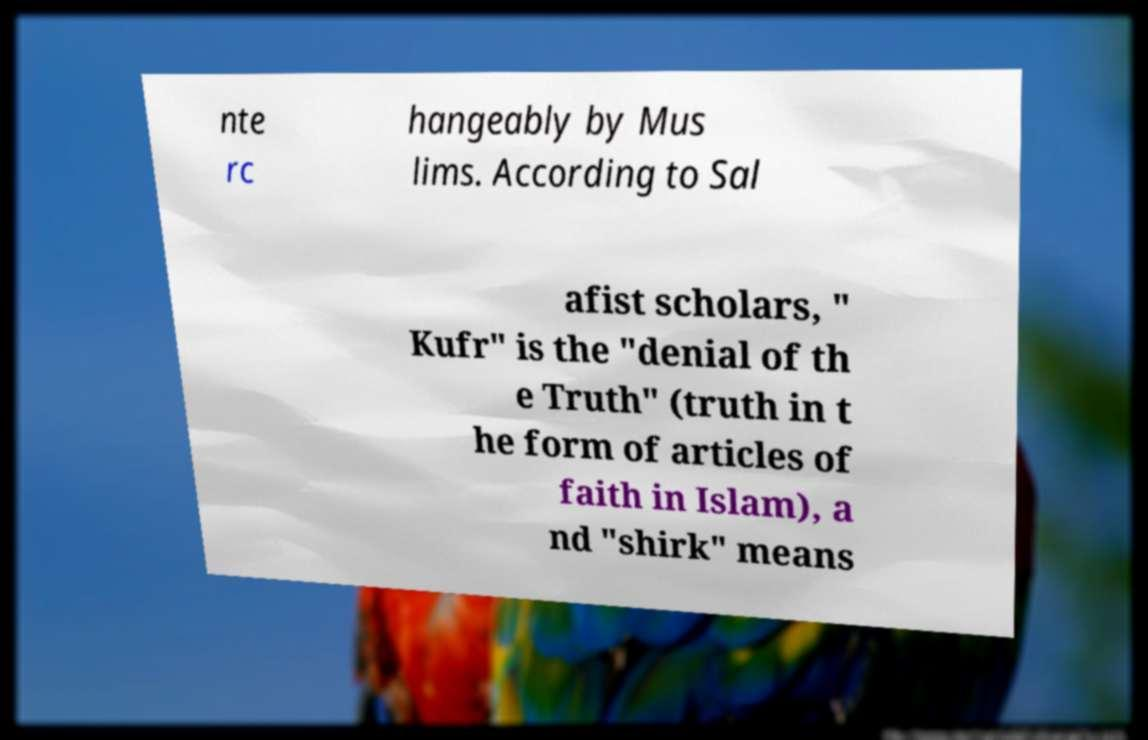What messages or text are displayed in this image? I need them in a readable, typed format. nte rc hangeably by Mus lims. According to Sal afist scholars, " Kufr" is the "denial of th e Truth" (truth in t he form of articles of faith in Islam), a nd "shirk" means 